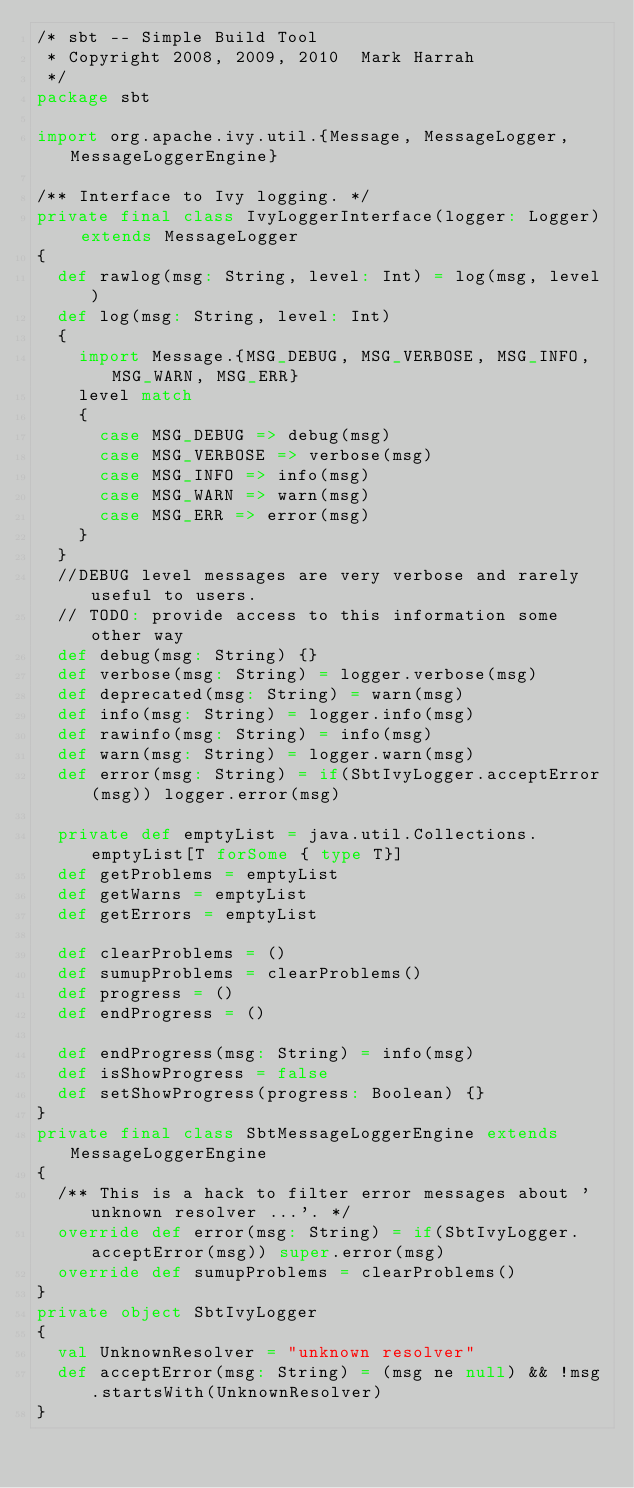<code> <loc_0><loc_0><loc_500><loc_500><_Scala_>/* sbt -- Simple Build Tool
 * Copyright 2008, 2009, 2010  Mark Harrah
 */
package sbt

import org.apache.ivy.util.{Message, MessageLogger, MessageLoggerEngine}

/** Interface to Ivy logging. */
private final class IvyLoggerInterface(logger: Logger) extends MessageLogger
{
	def rawlog(msg: String, level: Int) = log(msg, level)
	def log(msg: String, level: Int)
	{
		import Message.{MSG_DEBUG, MSG_VERBOSE, MSG_INFO, MSG_WARN, MSG_ERR}
		level match
		{
			case MSG_DEBUG => debug(msg)
			case MSG_VERBOSE => verbose(msg)
			case MSG_INFO => info(msg)
			case MSG_WARN => warn(msg)
			case MSG_ERR => error(msg)
		}
	}
	//DEBUG level messages are very verbose and rarely useful to users.
	// TODO: provide access to this information some other way
	def debug(msg: String) {}
	def verbose(msg: String) = logger.verbose(msg)
	def deprecated(msg: String) = warn(msg)
	def info(msg: String) = logger.info(msg)
	def rawinfo(msg: String) = info(msg)
	def warn(msg: String) = logger.warn(msg)
	def error(msg: String) = if(SbtIvyLogger.acceptError(msg)) logger.error(msg)
	
	private def emptyList = java.util.Collections.emptyList[T forSome { type T}]
	def getProblems = emptyList
	def getWarns = emptyList
	def getErrors = emptyList

	def clearProblems = ()
	def sumupProblems = clearProblems()
	def progress = ()
	def endProgress = ()

	def endProgress(msg: String) = info(msg)
	def isShowProgress = false
	def setShowProgress(progress: Boolean) {}
}
private final class SbtMessageLoggerEngine extends MessageLoggerEngine
{
	/** This is a hack to filter error messages about 'unknown resolver ...'. */
	override def error(msg: String) = if(SbtIvyLogger.acceptError(msg)) super.error(msg)
	override def sumupProblems = clearProblems()
}
private object SbtIvyLogger
{
	val UnknownResolver = "unknown resolver"
	def acceptError(msg: String) = (msg ne null) && !msg.startsWith(UnknownResolver)
}</code> 